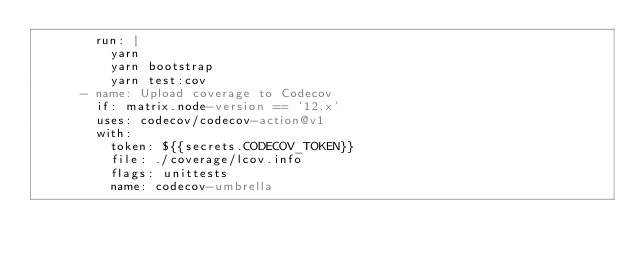Convert code to text. <code><loc_0><loc_0><loc_500><loc_500><_YAML_>        run: |
          yarn
          yarn bootstrap
          yarn test:cov
      - name: Upload coverage to Codecov
        if: matrix.node-version == '12.x'
        uses: codecov/codecov-action@v1
        with:
          token: ${{secrets.CODECOV_TOKEN}}
          file: ./coverage/lcov.info
          flags: unittests
          name: codecov-umbrella
</code> 